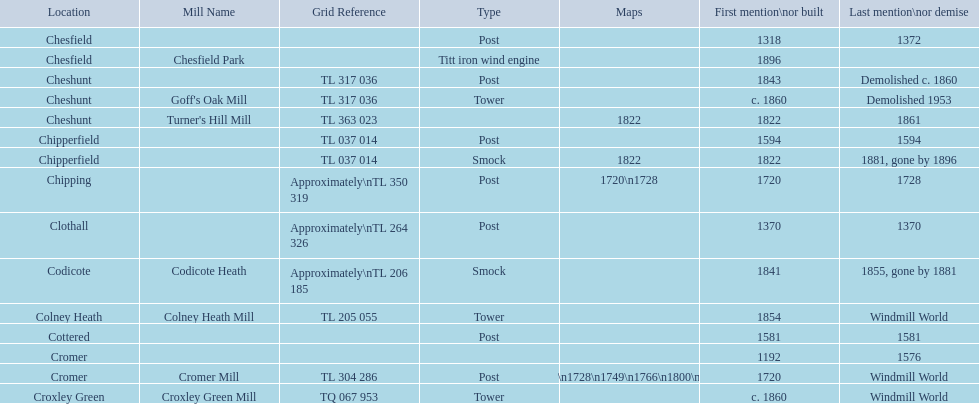What is the name of the only "c" mill located in colney health? Colney Heath Mill. 